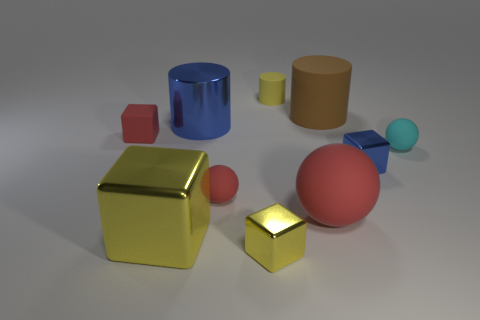There is a large metal thing behind the small red matte cube; what color is it?
Offer a very short reply. Blue. There is a large red thing; what shape is it?
Provide a succinct answer. Sphere. Is there a red matte thing that is to the right of the object that is behind the big matte object that is behind the big blue metal cylinder?
Your response must be concise. Yes. There is a tiny sphere that is to the left of the tiny metallic cube in front of the yellow object on the left side of the large blue metallic cylinder; what is its color?
Your response must be concise. Red. What material is the big red object that is the same shape as the tiny cyan rubber thing?
Your response must be concise. Rubber. There is a yellow shiny object that is behind the tiny yellow block right of the large yellow thing; how big is it?
Give a very brief answer. Large. There is a small thing that is behind the small red cube; what material is it?
Provide a short and direct response. Rubber. There is a block that is made of the same material as the tiny yellow cylinder; what is its size?
Your answer should be compact. Small. How many red rubber objects have the same shape as the tiny cyan rubber thing?
Your answer should be very brief. 2. There is a big blue metallic thing; is it the same shape as the big metal thing in front of the large red object?
Ensure brevity in your answer.  No. 